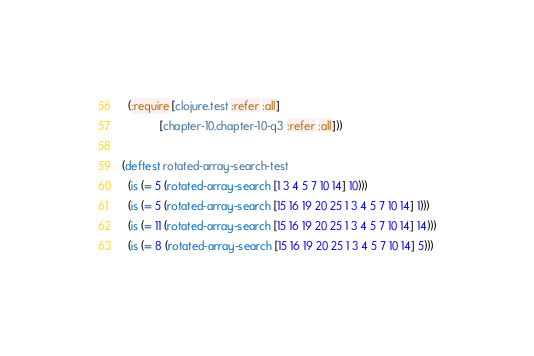Convert code to text. <code><loc_0><loc_0><loc_500><loc_500><_Clojure_>  (:require [clojure.test :refer :all]
            [chapter-10.chapter-10-q3 :refer :all]))

(deftest rotated-array-search-test
  (is (= 5 (rotated-array-search [1 3 4 5 7 10 14] 10)))
  (is (= 5 (rotated-array-search [15 16 19 20 25 1 3 4 5 7 10 14] 1)))
  (is (= 11 (rotated-array-search [15 16 19 20 25 1 3 4 5 7 10 14] 14)))
  (is (= 8 (rotated-array-search [15 16 19 20 25 1 3 4 5 7 10 14] 5)))</code> 